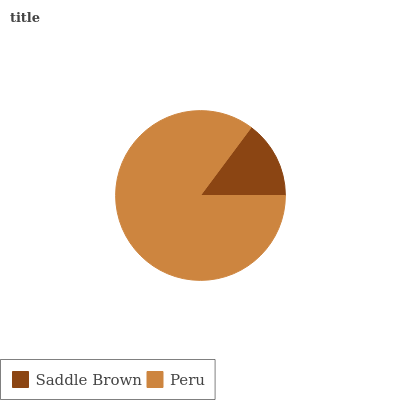Is Saddle Brown the minimum?
Answer yes or no. Yes. Is Peru the maximum?
Answer yes or no. Yes. Is Peru the minimum?
Answer yes or no. No. Is Peru greater than Saddle Brown?
Answer yes or no. Yes. Is Saddle Brown less than Peru?
Answer yes or no. Yes. Is Saddle Brown greater than Peru?
Answer yes or no. No. Is Peru less than Saddle Brown?
Answer yes or no. No. Is Peru the high median?
Answer yes or no. Yes. Is Saddle Brown the low median?
Answer yes or no. Yes. Is Saddle Brown the high median?
Answer yes or no. No. Is Peru the low median?
Answer yes or no. No. 